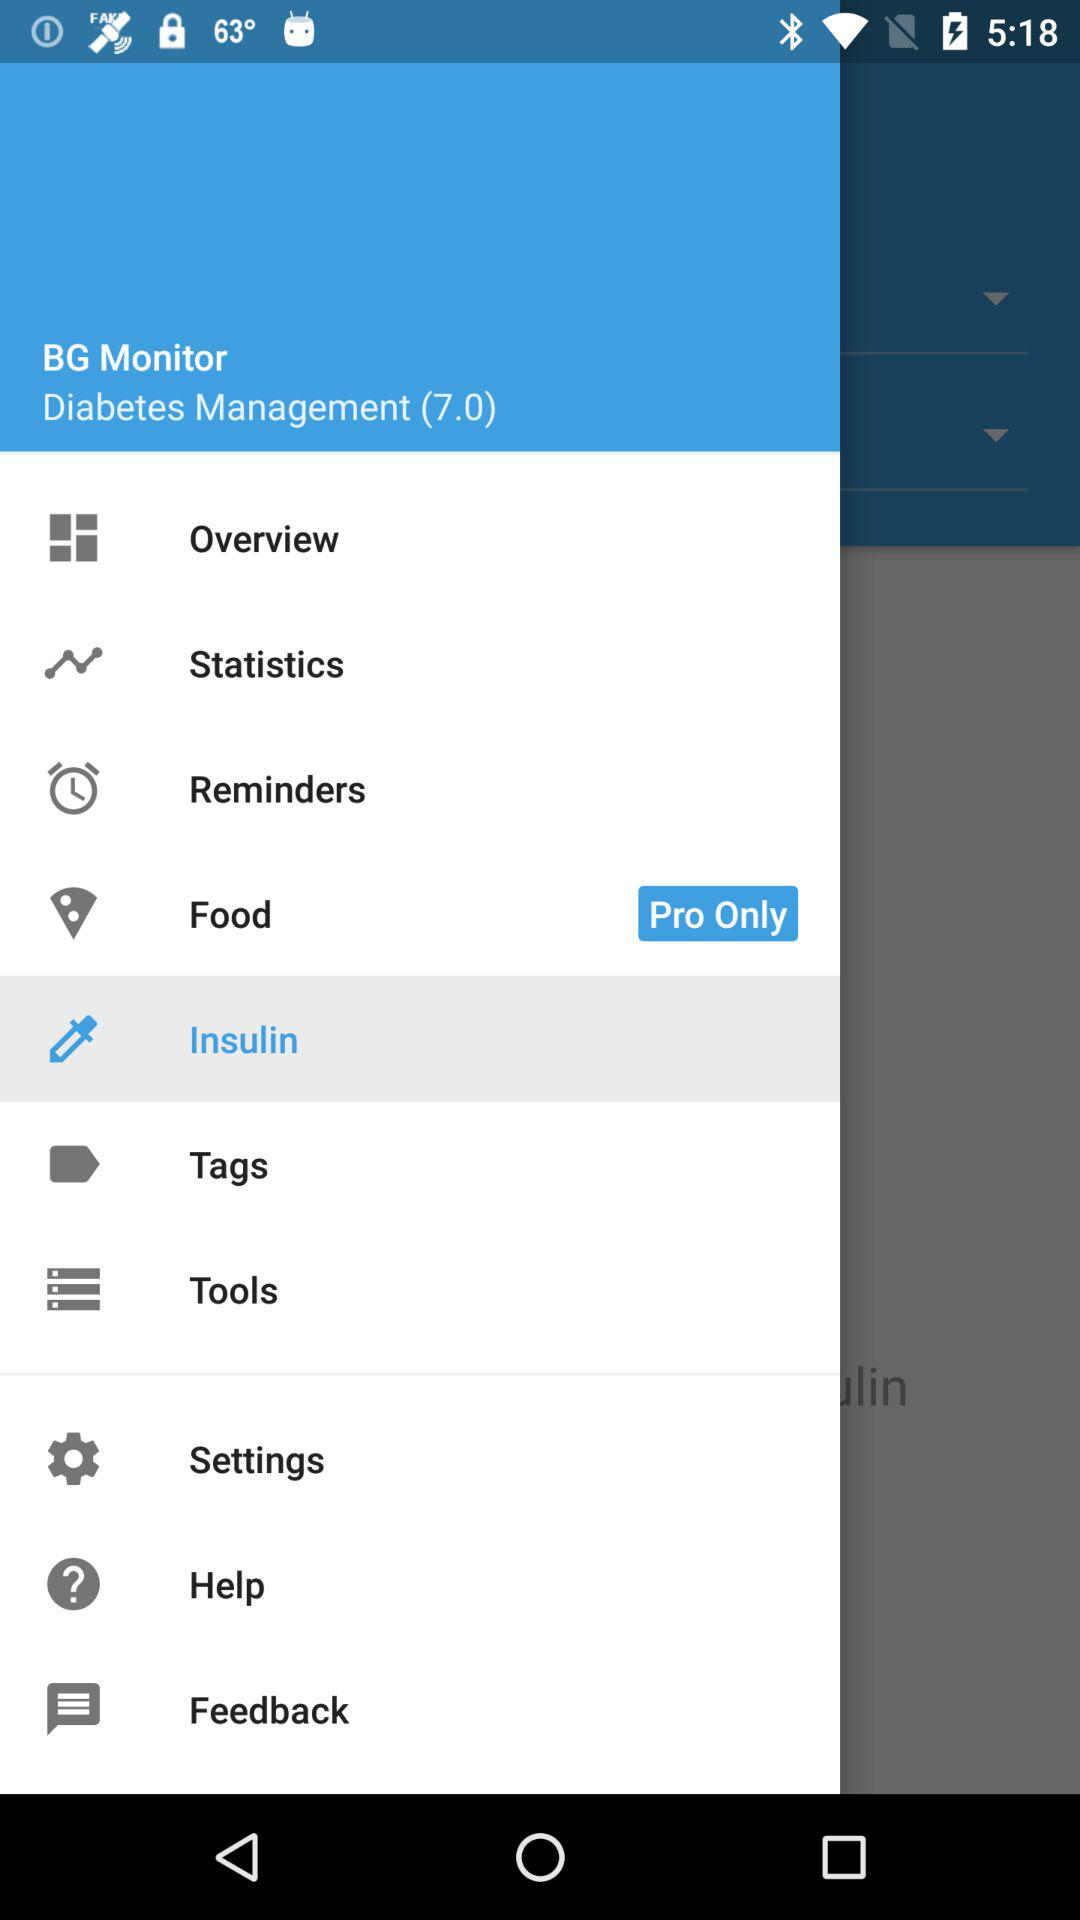What is the selected tab in the menu? The selected tab in the menu is "Insulin". 